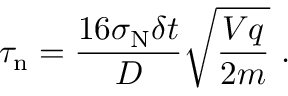<formula> <loc_0><loc_0><loc_500><loc_500>\tau _ { n } = \frac { 1 6 \sigma _ { N } \delta t } { D } \sqrt { \frac { V q } { 2 m } } \ .</formula> 